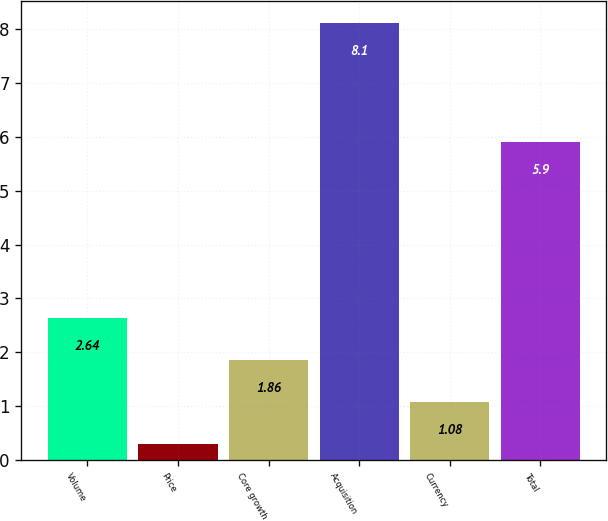Convert chart to OTSL. <chart><loc_0><loc_0><loc_500><loc_500><bar_chart><fcel>Volume<fcel>Price<fcel>Core growth<fcel>Acquisition<fcel>Currency<fcel>Total<nl><fcel>2.64<fcel>0.3<fcel>1.86<fcel>8.1<fcel>1.08<fcel>5.9<nl></chart> 